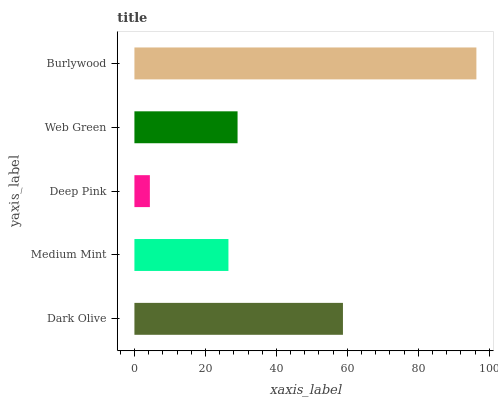Is Deep Pink the minimum?
Answer yes or no. Yes. Is Burlywood the maximum?
Answer yes or no. Yes. Is Medium Mint the minimum?
Answer yes or no. No. Is Medium Mint the maximum?
Answer yes or no. No. Is Dark Olive greater than Medium Mint?
Answer yes or no. Yes. Is Medium Mint less than Dark Olive?
Answer yes or no. Yes. Is Medium Mint greater than Dark Olive?
Answer yes or no. No. Is Dark Olive less than Medium Mint?
Answer yes or no. No. Is Web Green the high median?
Answer yes or no. Yes. Is Web Green the low median?
Answer yes or no. Yes. Is Medium Mint the high median?
Answer yes or no. No. Is Burlywood the low median?
Answer yes or no. No. 